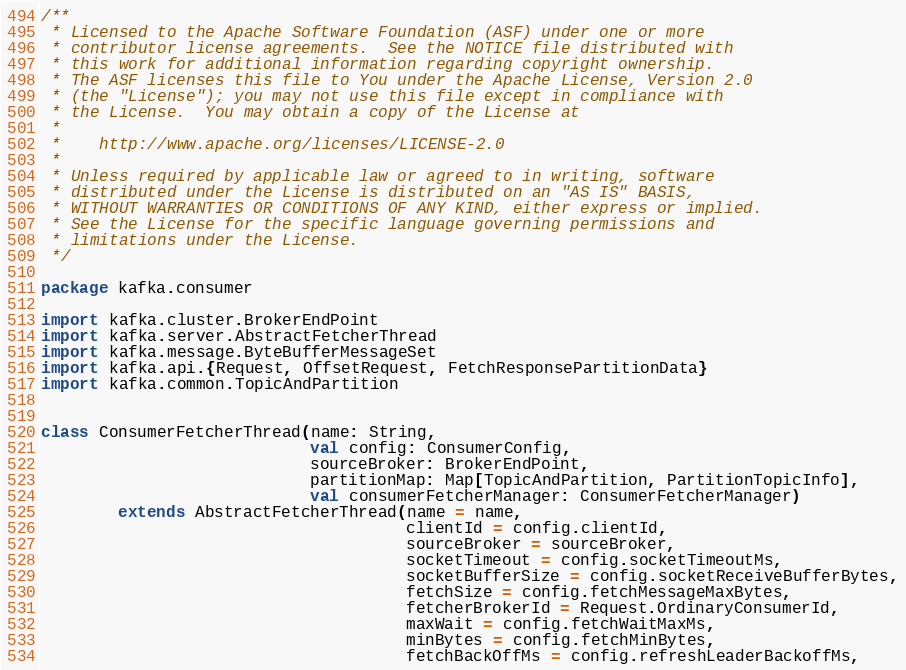Convert code to text. <code><loc_0><loc_0><loc_500><loc_500><_Scala_>/**
 * Licensed to the Apache Software Foundation (ASF) under one or more
 * contributor license agreements.  See the NOTICE file distributed with
 * this work for additional information regarding copyright ownership.
 * The ASF licenses this file to You under the Apache License, Version 2.0
 * (the "License"); you may not use this file except in compliance with
 * the License.  You may obtain a copy of the License at
 *
 *    http://www.apache.org/licenses/LICENSE-2.0
 *
 * Unless required by applicable law or agreed to in writing, software
 * distributed under the License is distributed on an "AS IS" BASIS,
 * WITHOUT WARRANTIES OR CONDITIONS OF ANY KIND, either express or implied.
 * See the License for the specific language governing permissions and
 * limitations under the License.
 */

package kafka.consumer

import kafka.cluster.BrokerEndPoint
import kafka.server.AbstractFetcherThread
import kafka.message.ByteBufferMessageSet
import kafka.api.{Request, OffsetRequest, FetchResponsePartitionData}
import kafka.common.TopicAndPartition


class ConsumerFetcherThread(name: String,
                            val config: ConsumerConfig,
                            sourceBroker: BrokerEndPoint,
                            partitionMap: Map[TopicAndPartition, PartitionTopicInfo],
                            val consumerFetcherManager: ConsumerFetcherManager)
        extends AbstractFetcherThread(name = name,
                                      clientId = config.clientId,
                                      sourceBroker = sourceBroker,
                                      socketTimeout = config.socketTimeoutMs,
                                      socketBufferSize = config.socketReceiveBufferBytes,
                                      fetchSize = config.fetchMessageMaxBytes,
                                      fetcherBrokerId = Request.OrdinaryConsumerId,
                                      maxWait = config.fetchWaitMaxMs,
                                      minBytes = config.fetchMinBytes,
                                      fetchBackOffMs = config.refreshLeaderBackoffMs,</code> 